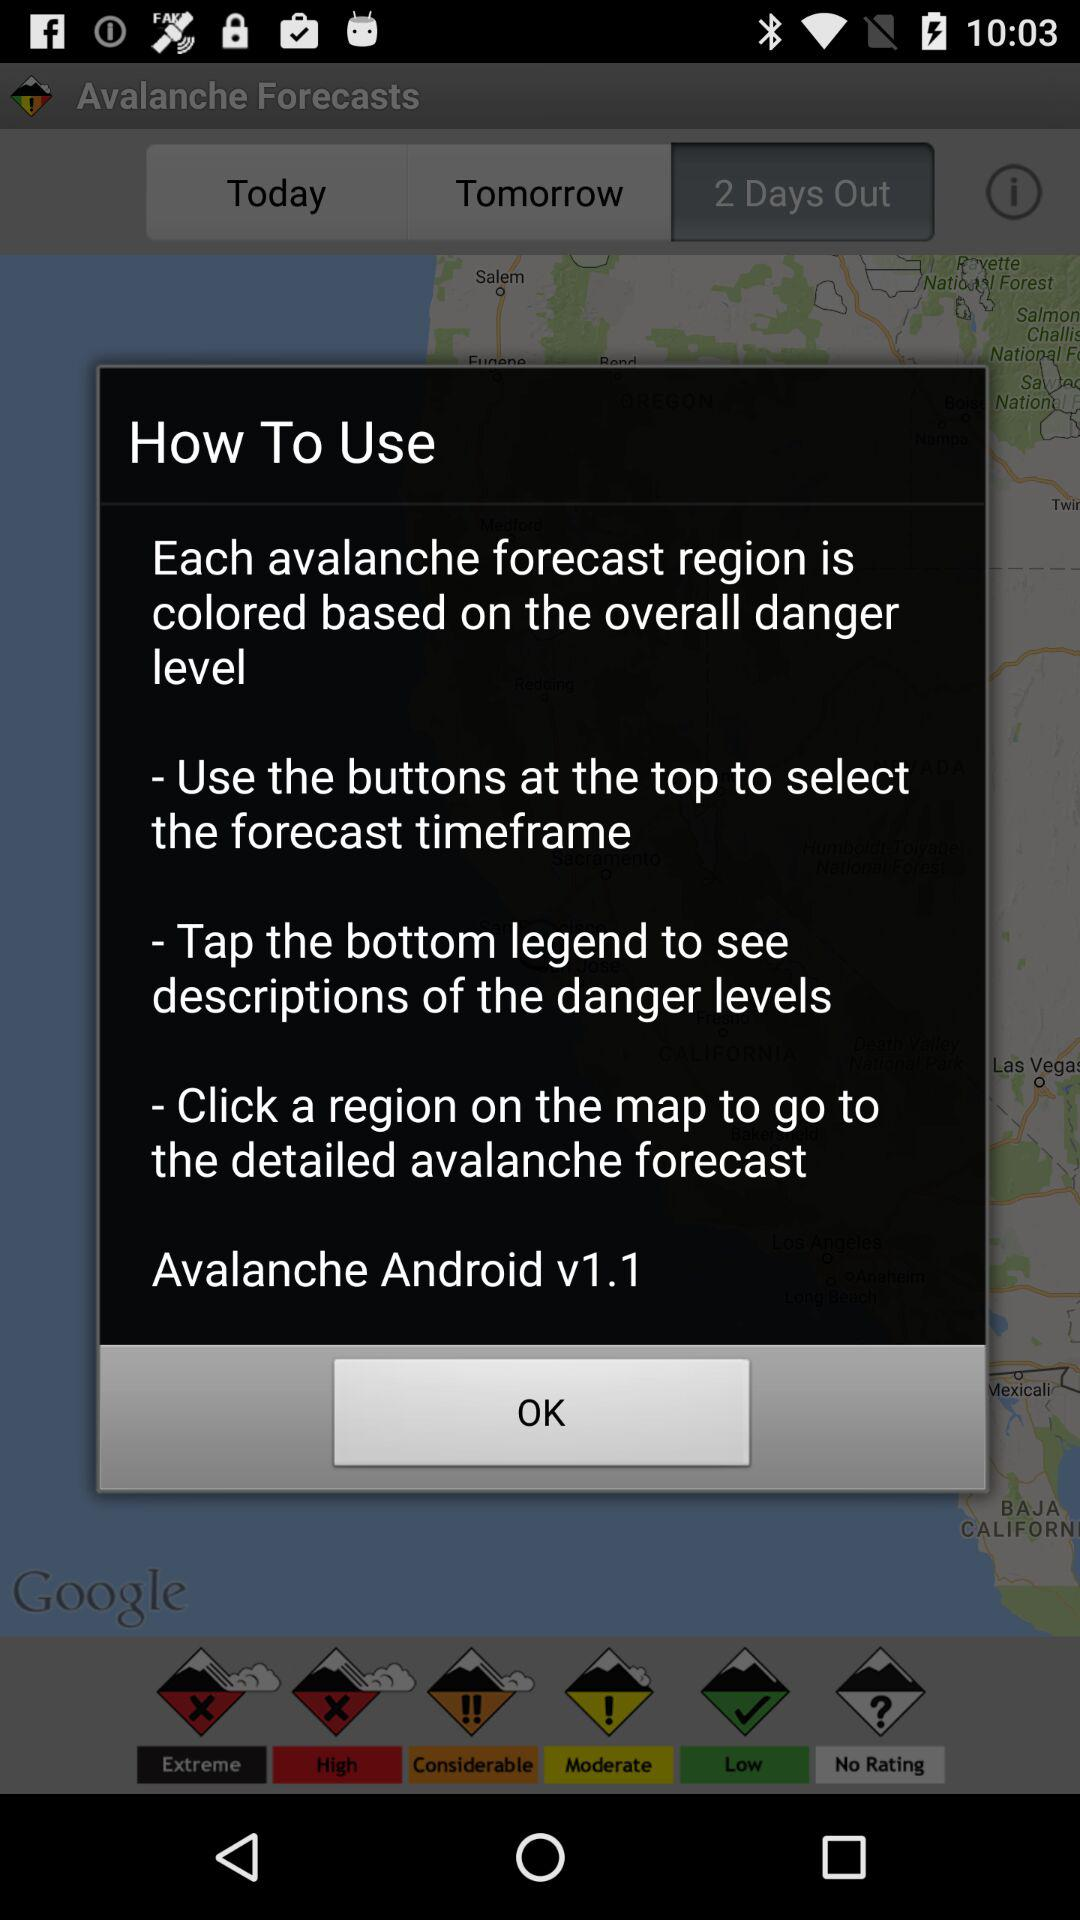Which tab is selected? The selected tab is "2 Days Out". 